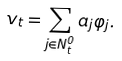<formula> <loc_0><loc_0><loc_500><loc_500>v _ { t } = \sum _ { j \in N _ { t } ^ { 0 } } a _ { j } \varphi _ { j } .</formula> 